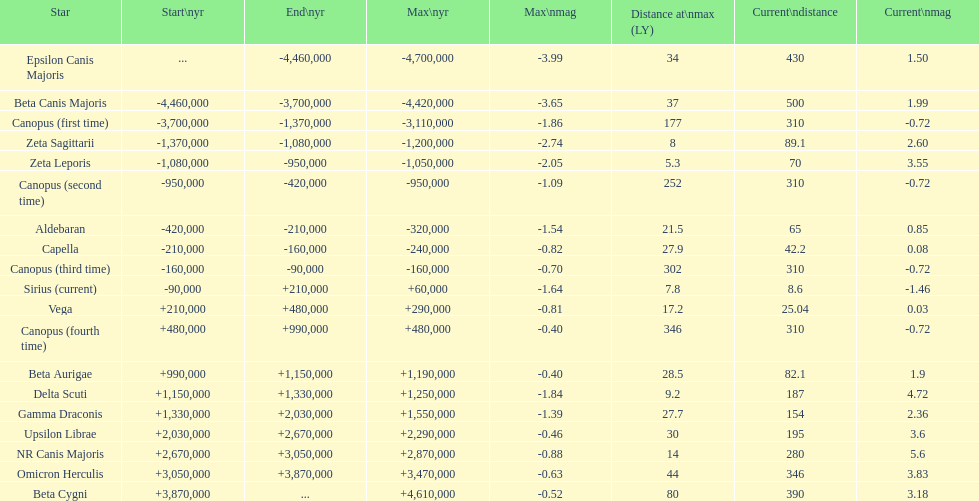How many stars have a distance at maximum of 30 light years or higher? 9. 